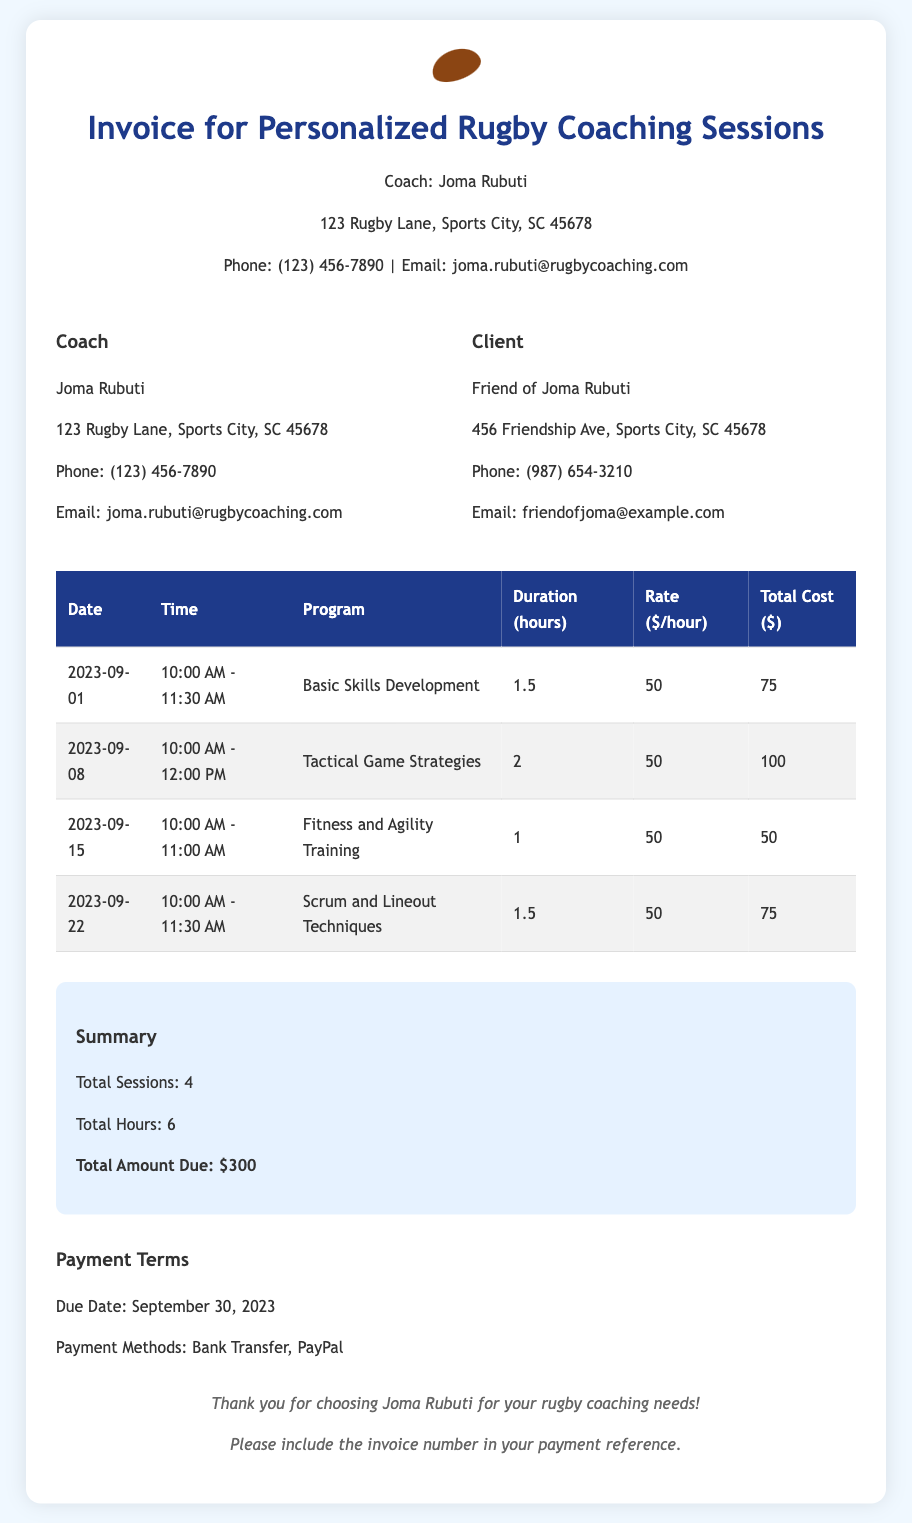What is the total amount due? The total amount due is stated in the summary section of the invoice.
Answer: $300 What date is the invoice due? The due date for payment is mentioned in the payment terms section of the invoice.
Answer: September 30, 2023 What is the rate per hour for coaching sessions? The rate for each hour of coaching is consistently listed in the table for each session.
Answer: $50 How many total sessions are listed in the invoice? The total number of sessions is provided in the summary section at the bottom of the invoice.
Answer: 4 What is the program for the session on September 8? The program for each session is outlined in the table, particularly for the specified date.
Answer: Tactical Game Strategies What is the duration of the Fitness and Agility Training session? The duration for each session is listed in the corresponding table row, specifically for that program.
Answer: 1 hour Which payment methods are accepted? The payment terms section specifies the methods available for payment.
Answer: Bank Transfer, PayPal What is the total hours of coaching mentioned? The total hours of coaching sessions provided is included in the summary section.
Answer: 6 